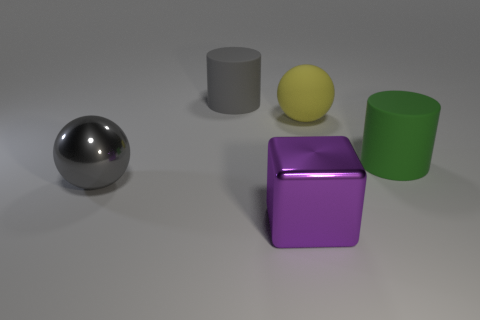Add 1 purple objects. How many objects exist? 6 Subtract all balls. How many objects are left? 3 Subtract all gray rubber things. Subtract all big yellow rubber balls. How many objects are left? 3 Add 5 big metallic balls. How many big metallic balls are left? 6 Add 4 big shiny objects. How many big shiny objects exist? 6 Subtract 1 gray cylinders. How many objects are left? 4 